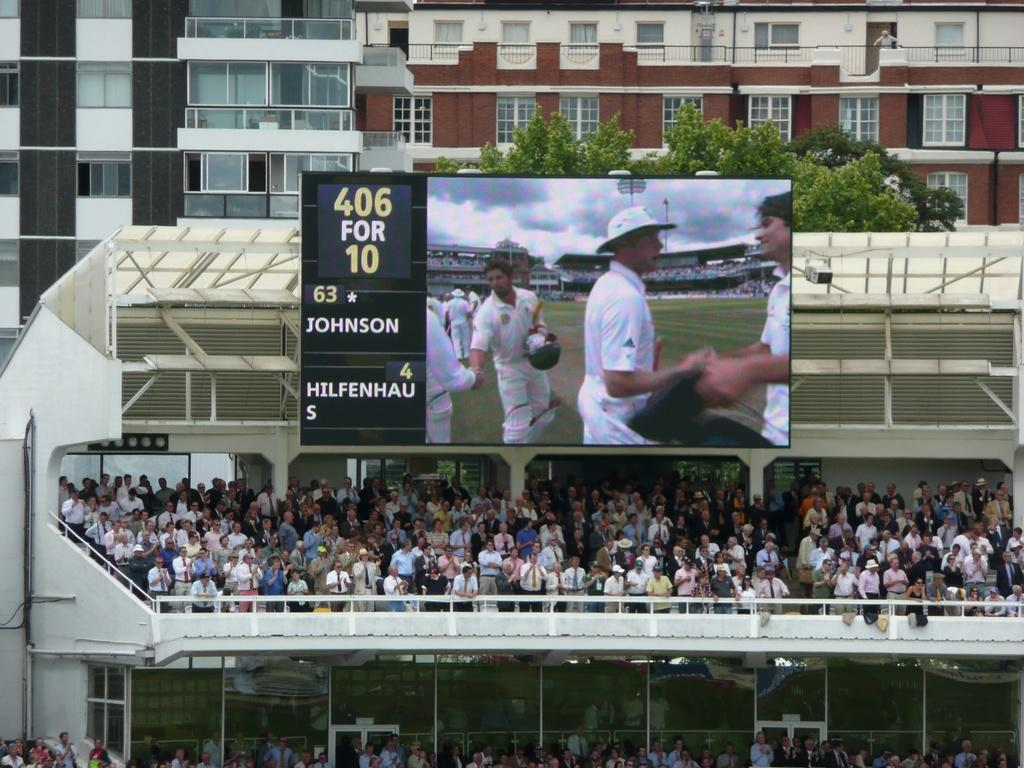<image>
Give a short and clear explanation of the subsequent image. A score board reads 46 for 10 above the crowd in the stadium 